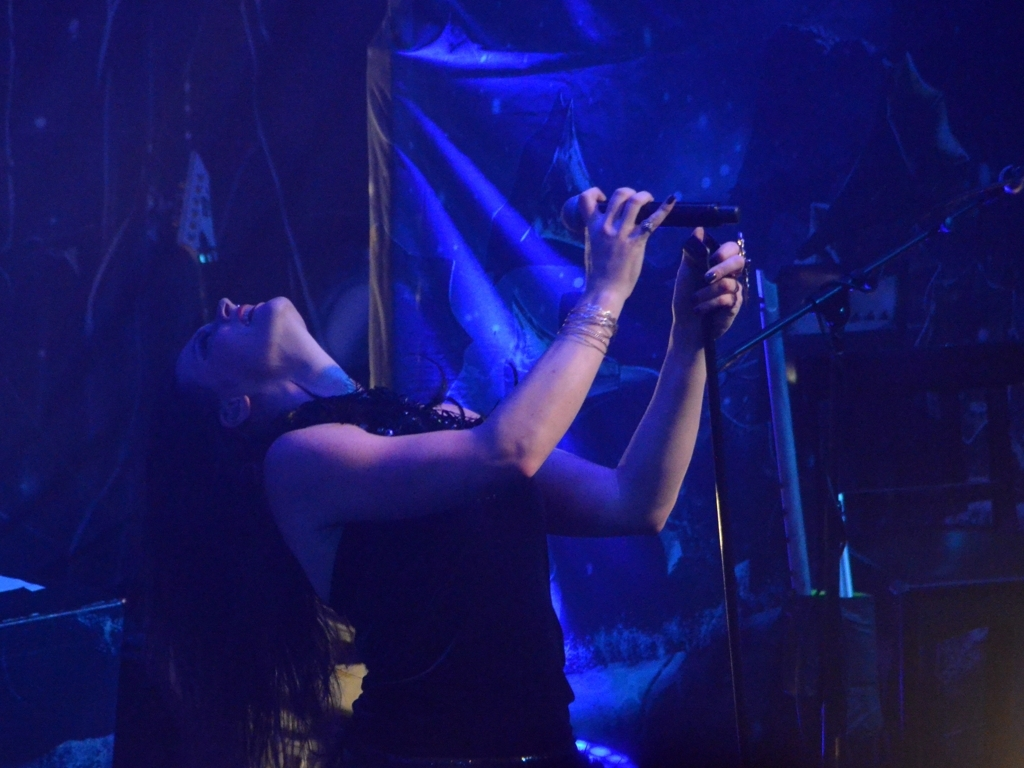What is the atmosphere conveyed by the image? The image exudes a dramatic and intense atmosphere, emphasized by the stark stage lighting and the performer's expressive posture, suggesting an engaging live music experience. 